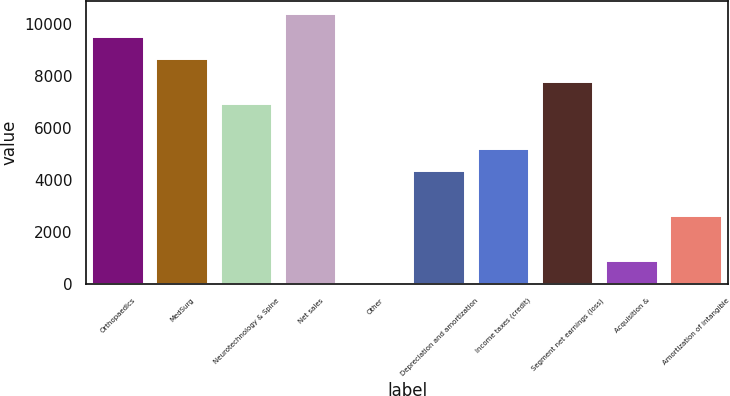Convert chart to OTSL. <chart><loc_0><loc_0><loc_500><loc_500><bar_chart><fcel>Orthopaedics<fcel>MedSurg<fcel>Neurotechnology & Spine<fcel>Net sales<fcel>Other<fcel>Depreciation and amortization<fcel>Income taxes (credit)<fcel>Segment net earnings (loss)<fcel>Acquisition &<fcel>Amortization of intangible<nl><fcel>9521.9<fcel>8657<fcel>6927.2<fcel>10386.8<fcel>8<fcel>4332.5<fcel>5197.4<fcel>7792.1<fcel>872.9<fcel>2602.7<nl></chart> 